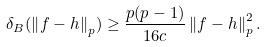Convert formula to latex. <formula><loc_0><loc_0><loc_500><loc_500>\delta _ { B } ( \left \| f - h \right \| _ { p } ) \geq \frac { p ( p - 1 ) } { 1 6 c } \left \| f - h \right \| _ { p } ^ { 2 } .</formula> 